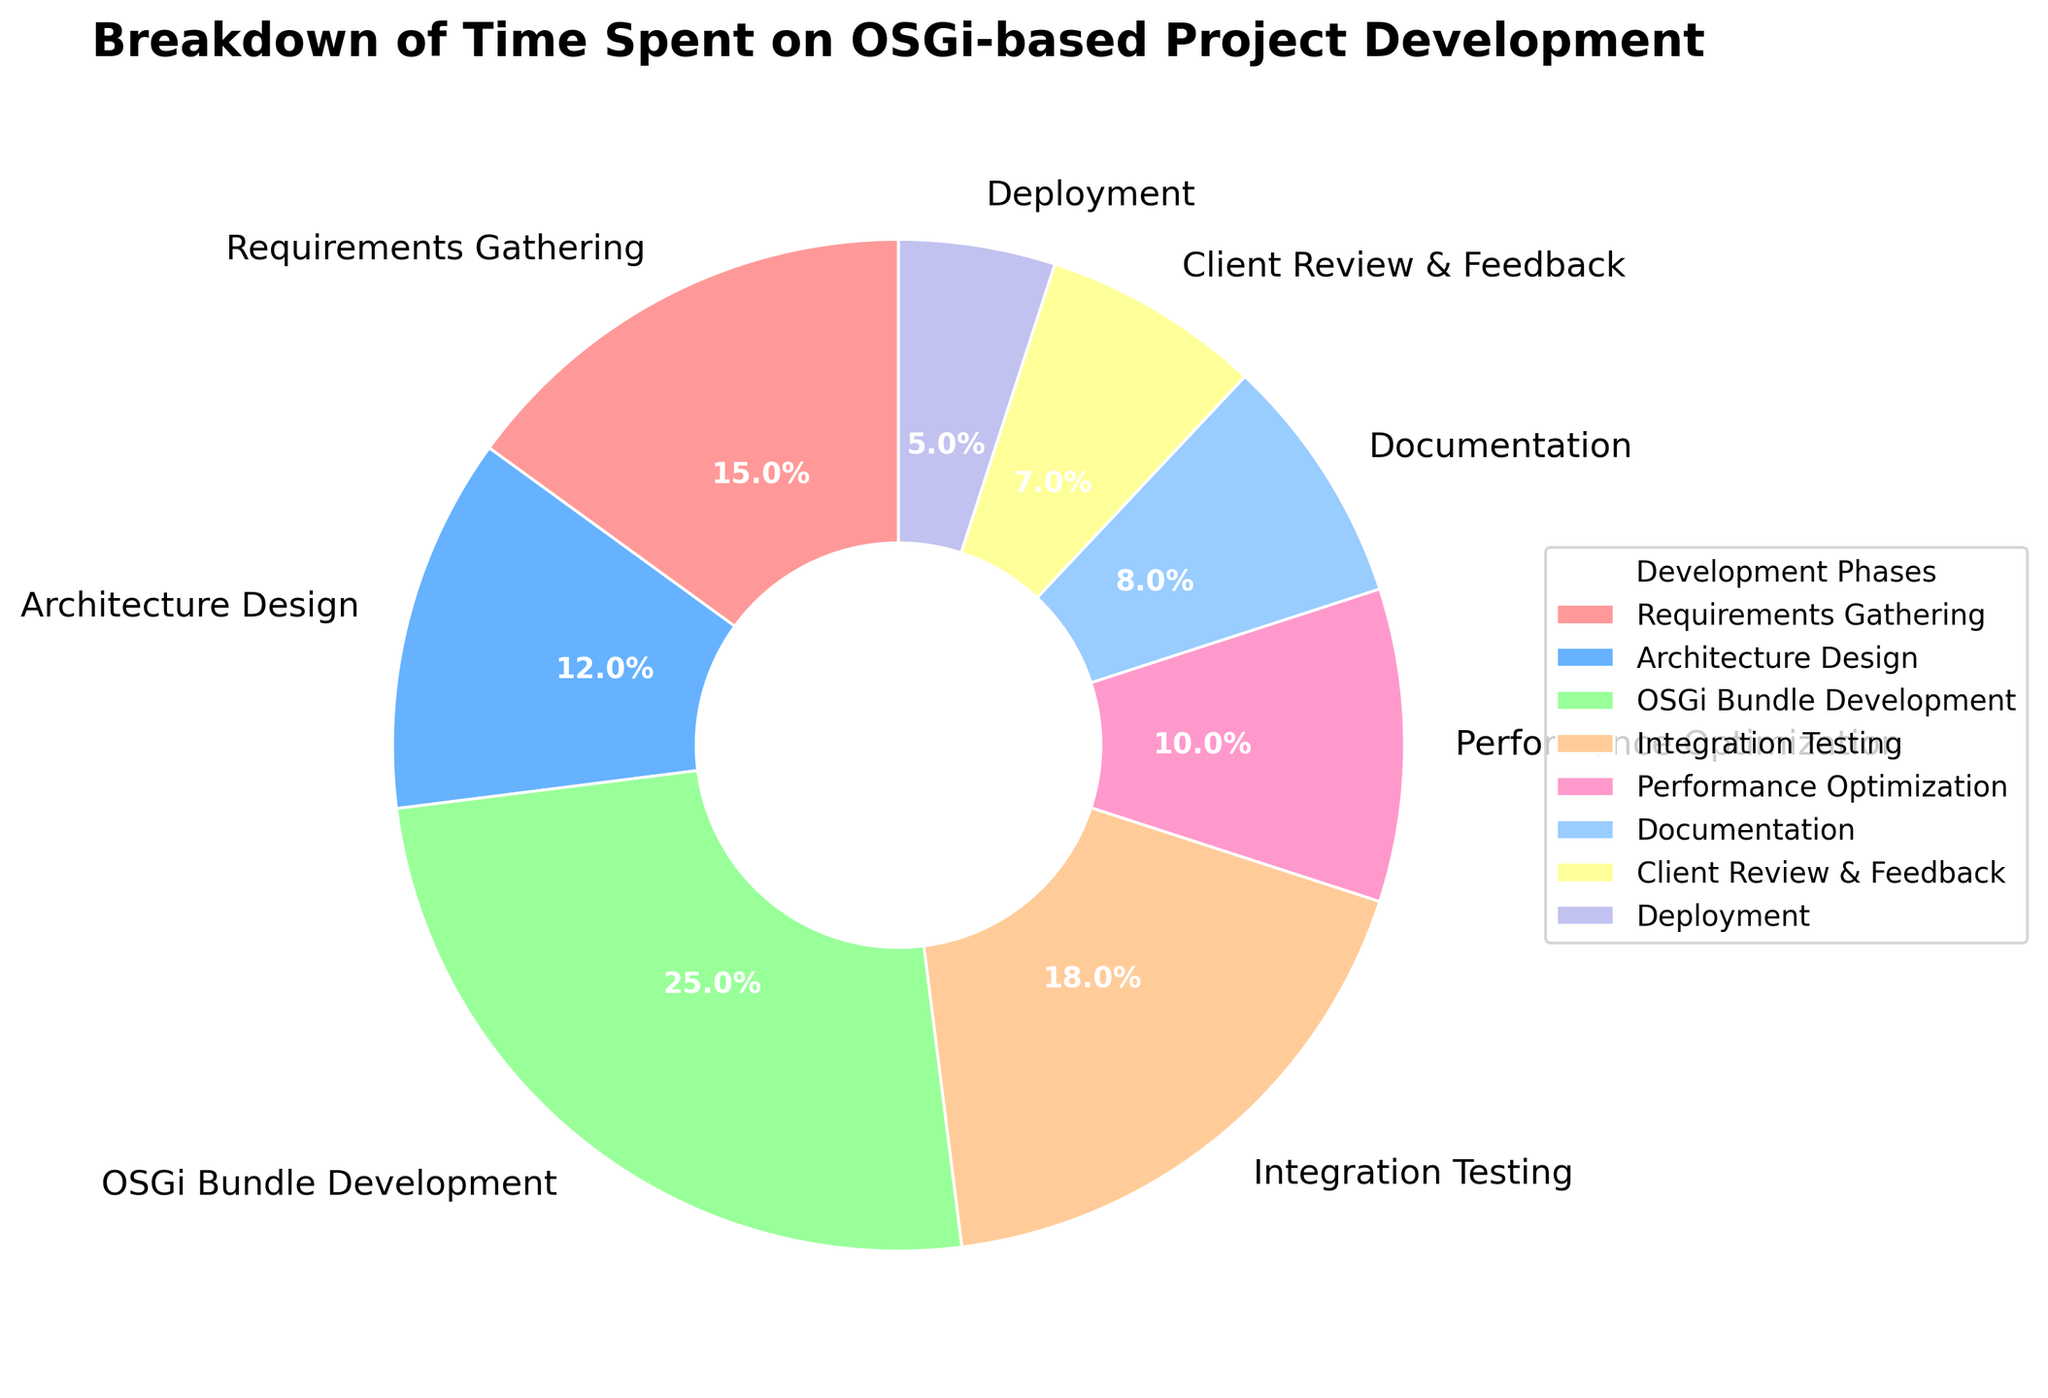What phase takes the largest percentage of time? The segment representing "OSGi Bundle Development" is the largest in the pie chart, indicating it consumes the most time.
Answer: OSGi Bundle Development How much more time is spent on Integration Testing compared to Deployment? Integration Testing is 18% and Deployment is 5%. The difference is 18% - 5% = 13%.
Answer: 13% Which phases have the same or almost the same percentage of time allocation? The percentages are 15, 12, 25, 18, 10, 8, 7, 5. "Architecture Design" (12%) and "Documentation" (8%) are the closest, with a 4% difference.
Answer: Architecture Design and Documentation What is the total percentage of time spent on both Requirements Gathering and Client Review & Feedback? Requirements Gathering is 15% and Client Review & Feedback is 7%. Adding these gives 15% + 7% = 22%.
Answer: 22% What is the combined time spent on Performance Optimization, Documentation, and Deployment? Performance Optimization is 10%, Documentation is 8%, and Deployment is 5%. The sum is 10% + 8% + 5% = 23%.
Answer: 23% Which phase is represented by the yellow segment? By visual inspection, the pie chart segment colored yellow represents "Deployment."
Answer: Deployment How does the time spent on Architecture Design compare with Performance Optimization? Architecture Design takes 12%, while Performance Optimization takes 10%. Thus, Architecture Design takes 2% more time.
Answer: 2% more What are the two phases with the smallest time allocation, and what are their percentages? The smallest slices represent Deployment at 5% and Client Review & Feedback at 7%.
Answer: Deployment and Client Review & Feedback, 5% and 7% respectively Is the percentage of time spent on OSGi Bundle Development more than twice that of Documentation? OSGi Bundle Development is 25% and Documentation is 8%. Twice of Documentation is 2 * 8% = 16%. Since 25% > 16%, the answer is yes.
Answer: Yes 